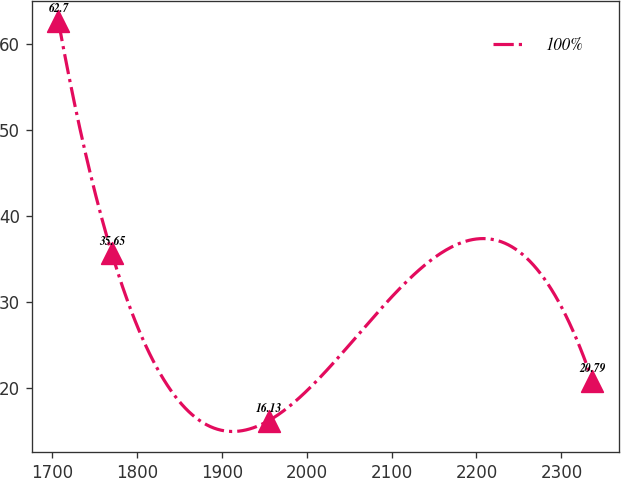<chart> <loc_0><loc_0><loc_500><loc_500><line_chart><ecel><fcel>100%<nl><fcel>1707.7<fcel>62.7<nl><fcel>1770.58<fcel>35.65<nl><fcel>1955.17<fcel>16.13<nl><fcel>2336.47<fcel>20.79<nl></chart> 